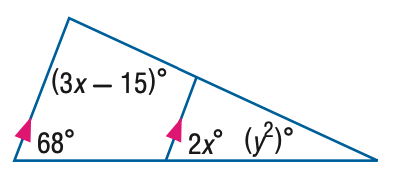Answer the mathemtical geometry problem and directly provide the correct option letter.
Question: Find y in the figure.
Choices: A: 5 B: 6 C: 25 D: 36 A 